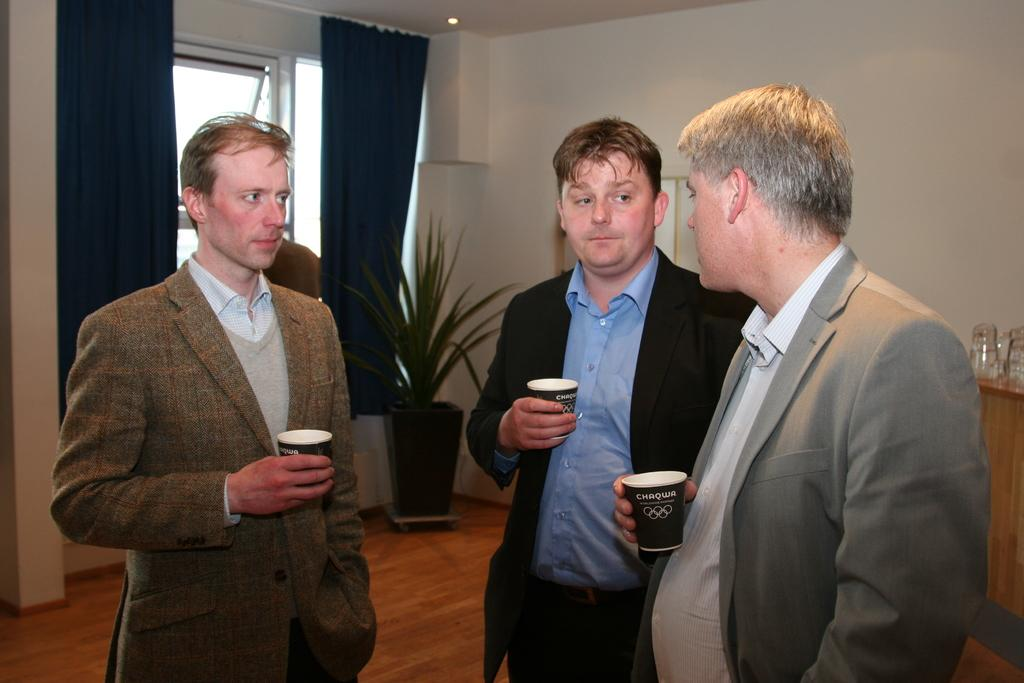How many people are present in the image? There are three people in the image. What are the people wearing? The people are wearing suits. What are the people holding in their hands? The people are holding cups. What can be seen in the background of the image? There is a plant, a window with curtains, and a wall in the background of the image. What is on the table in the image? There are objects on the table. What type of butter is being spread on the bit of bread in the image? There is no bread or butter present in the image; the people are holding cups and there are objects on the table. 